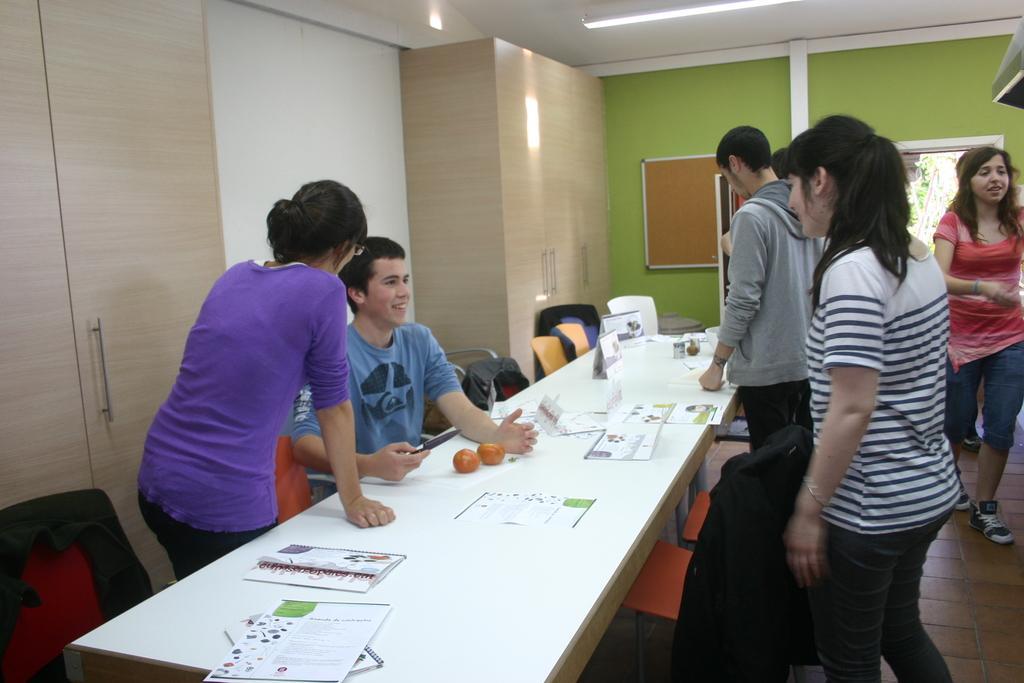Can you describe this image briefly? These persons are standing. This persons walking. This person sitting on the chair. We can see chairs and tables. On the table we can see paper,book,food. On the background we can see wall,board. On the top we can see light. This is floor. 